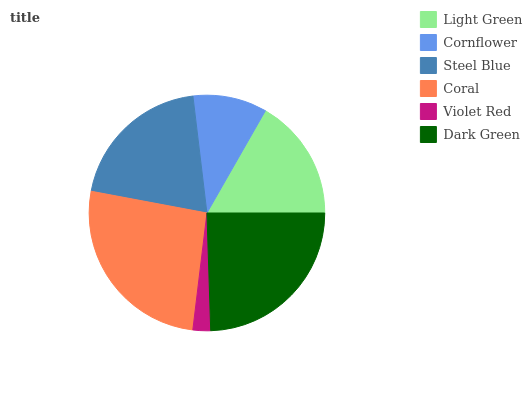Is Violet Red the minimum?
Answer yes or no. Yes. Is Coral the maximum?
Answer yes or no. Yes. Is Cornflower the minimum?
Answer yes or no. No. Is Cornflower the maximum?
Answer yes or no. No. Is Light Green greater than Cornflower?
Answer yes or no. Yes. Is Cornflower less than Light Green?
Answer yes or no. Yes. Is Cornflower greater than Light Green?
Answer yes or no. No. Is Light Green less than Cornflower?
Answer yes or no. No. Is Steel Blue the high median?
Answer yes or no. Yes. Is Light Green the low median?
Answer yes or no. Yes. Is Cornflower the high median?
Answer yes or no. No. Is Steel Blue the low median?
Answer yes or no. No. 